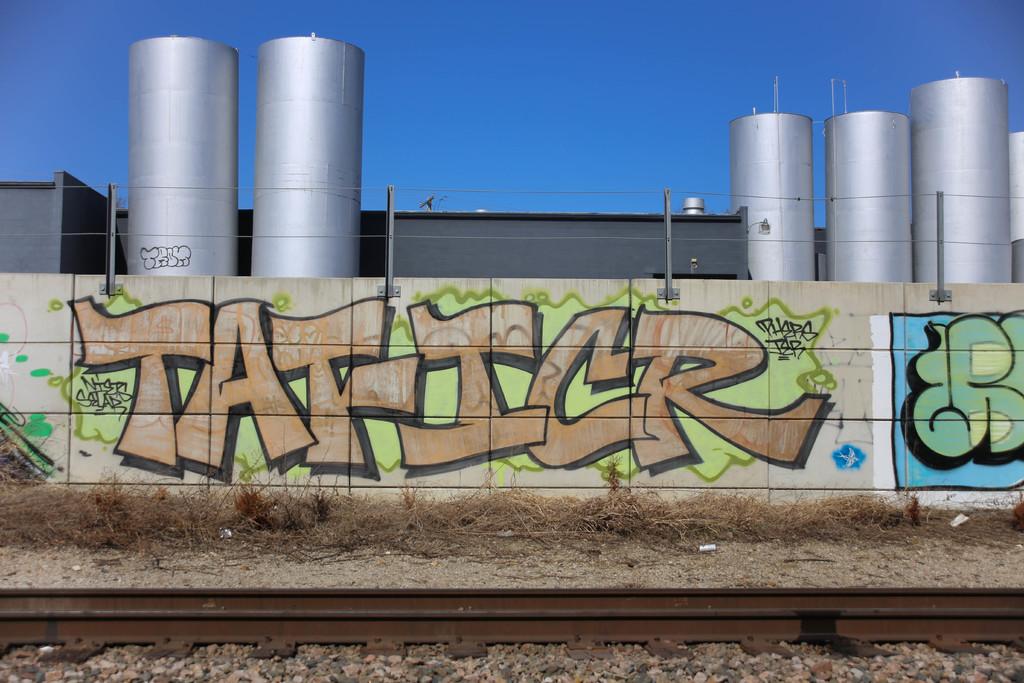What does this graffiti say?
Your answer should be compact. Tat-icr. 